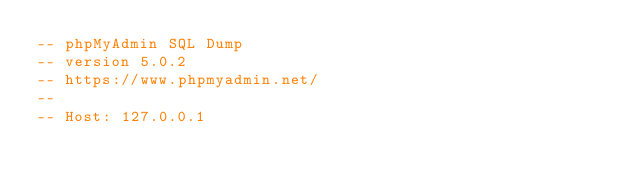Convert code to text. <code><loc_0><loc_0><loc_500><loc_500><_SQL_>-- phpMyAdmin SQL Dump
-- version 5.0.2
-- https://www.phpmyadmin.net/
--
-- Host: 127.0.0.1</code> 